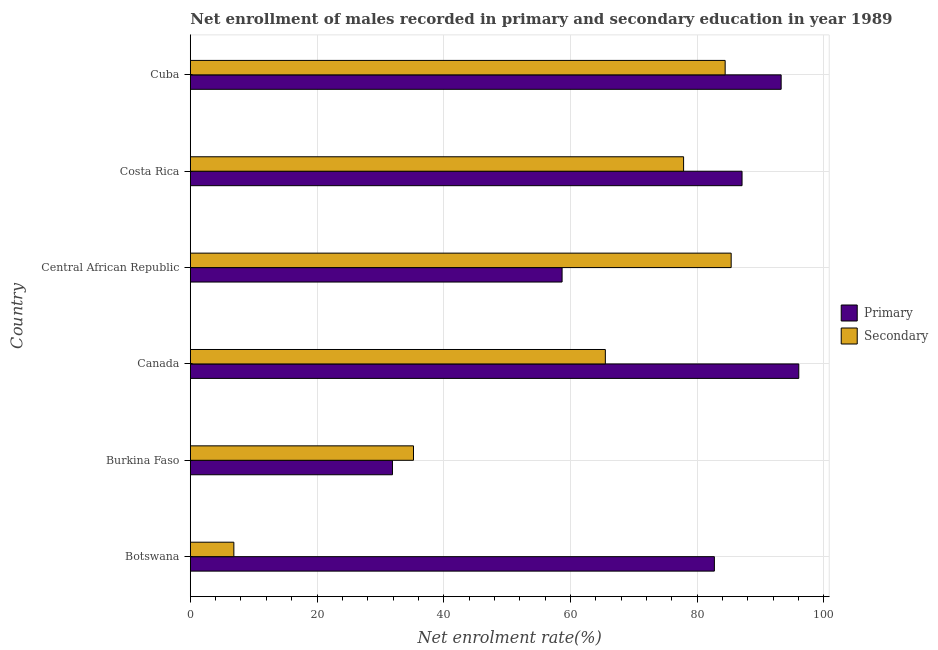How many different coloured bars are there?
Provide a succinct answer. 2. How many groups of bars are there?
Provide a short and direct response. 6. Are the number of bars on each tick of the Y-axis equal?
Your answer should be very brief. Yes. How many bars are there on the 3rd tick from the top?
Offer a very short reply. 2. What is the label of the 6th group of bars from the top?
Your response must be concise. Botswana. What is the enrollment rate in primary education in Burkina Faso?
Your answer should be compact. 31.91. Across all countries, what is the maximum enrollment rate in primary education?
Keep it short and to the point. 96.04. Across all countries, what is the minimum enrollment rate in secondary education?
Provide a succinct answer. 6.88. In which country was the enrollment rate in secondary education maximum?
Make the answer very short. Central African Republic. In which country was the enrollment rate in primary education minimum?
Offer a terse response. Burkina Faso. What is the total enrollment rate in secondary education in the graph?
Provide a succinct answer. 355.25. What is the difference between the enrollment rate in primary education in Canada and that in Cuba?
Provide a short and direct response. 2.78. What is the difference between the enrollment rate in secondary education in Central African Republic and the enrollment rate in primary education in Burkina Faso?
Offer a very short reply. 53.46. What is the average enrollment rate in primary education per country?
Keep it short and to the point. 74.95. What is the difference between the enrollment rate in primary education and enrollment rate in secondary education in Botswana?
Offer a terse response. 75.84. What is the ratio of the enrollment rate in secondary education in Botswana to that in Costa Rica?
Your response must be concise. 0.09. Is the enrollment rate in primary education in Burkina Faso less than that in Canada?
Give a very brief answer. Yes. Is the difference between the enrollment rate in primary education in Botswana and Central African Republic greater than the difference between the enrollment rate in secondary education in Botswana and Central African Republic?
Give a very brief answer. Yes. What is the difference between the highest and the second highest enrollment rate in primary education?
Your response must be concise. 2.78. What is the difference between the highest and the lowest enrollment rate in secondary education?
Provide a short and direct response. 78.49. In how many countries, is the enrollment rate in primary education greater than the average enrollment rate in primary education taken over all countries?
Provide a succinct answer. 4. What does the 2nd bar from the top in Costa Rica represents?
Provide a short and direct response. Primary. What does the 2nd bar from the bottom in Canada represents?
Offer a terse response. Secondary. Are all the bars in the graph horizontal?
Provide a short and direct response. Yes. How many countries are there in the graph?
Your answer should be very brief. 6. What is the difference between two consecutive major ticks on the X-axis?
Provide a succinct answer. 20. Are the values on the major ticks of X-axis written in scientific E-notation?
Your response must be concise. No. Does the graph contain grids?
Your answer should be compact. Yes. How many legend labels are there?
Your answer should be very brief. 2. What is the title of the graph?
Ensure brevity in your answer.  Net enrollment of males recorded in primary and secondary education in year 1989. Does "National Visitors" appear as one of the legend labels in the graph?
Provide a short and direct response. No. What is the label or title of the X-axis?
Your answer should be very brief. Net enrolment rate(%). What is the label or title of the Y-axis?
Give a very brief answer. Country. What is the Net enrolment rate(%) in Primary in Botswana?
Offer a terse response. 82.72. What is the Net enrolment rate(%) of Secondary in Botswana?
Provide a short and direct response. 6.88. What is the Net enrolment rate(%) of Primary in Burkina Faso?
Your answer should be very brief. 31.91. What is the Net enrolment rate(%) of Secondary in Burkina Faso?
Your answer should be very brief. 35.23. What is the Net enrolment rate(%) in Primary in Canada?
Offer a very short reply. 96.04. What is the Net enrolment rate(%) in Secondary in Canada?
Offer a very short reply. 65.51. What is the Net enrolment rate(%) in Primary in Central African Republic?
Offer a terse response. 58.68. What is the Net enrolment rate(%) of Secondary in Central African Republic?
Ensure brevity in your answer.  85.37. What is the Net enrolment rate(%) of Primary in Costa Rica?
Offer a very short reply. 87.08. What is the Net enrolment rate(%) of Secondary in Costa Rica?
Make the answer very short. 77.86. What is the Net enrolment rate(%) of Primary in Cuba?
Ensure brevity in your answer.  93.25. What is the Net enrolment rate(%) of Secondary in Cuba?
Provide a short and direct response. 84.42. Across all countries, what is the maximum Net enrolment rate(%) of Primary?
Make the answer very short. 96.04. Across all countries, what is the maximum Net enrolment rate(%) of Secondary?
Your answer should be very brief. 85.37. Across all countries, what is the minimum Net enrolment rate(%) in Primary?
Your response must be concise. 31.91. Across all countries, what is the minimum Net enrolment rate(%) in Secondary?
Offer a terse response. 6.88. What is the total Net enrolment rate(%) in Primary in the graph?
Your answer should be very brief. 449.68. What is the total Net enrolment rate(%) of Secondary in the graph?
Provide a short and direct response. 355.25. What is the difference between the Net enrolment rate(%) in Primary in Botswana and that in Burkina Faso?
Keep it short and to the point. 50.81. What is the difference between the Net enrolment rate(%) of Secondary in Botswana and that in Burkina Faso?
Offer a terse response. -28.35. What is the difference between the Net enrolment rate(%) in Primary in Botswana and that in Canada?
Your answer should be very brief. -13.32. What is the difference between the Net enrolment rate(%) of Secondary in Botswana and that in Canada?
Make the answer very short. -58.63. What is the difference between the Net enrolment rate(%) in Primary in Botswana and that in Central African Republic?
Provide a short and direct response. 24.04. What is the difference between the Net enrolment rate(%) of Secondary in Botswana and that in Central African Republic?
Your response must be concise. -78.49. What is the difference between the Net enrolment rate(%) in Primary in Botswana and that in Costa Rica?
Provide a succinct answer. -4.37. What is the difference between the Net enrolment rate(%) of Secondary in Botswana and that in Costa Rica?
Ensure brevity in your answer.  -70.98. What is the difference between the Net enrolment rate(%) in Primary in Botswana and that in Cuba?
Offer a very short reply. -10.54. What is the difference between the Net enrolment rate(%) of Secondary in Botswana and that in Cuba?
Provide a short and direct response. -77.54. What is the difference between the Net enrolment rate(%) in Primary in Burkina Faso and that in Canada?
Your answer should be compact. -64.13. What is the difference between the Net enrolment rate(%) of Secondary in Burkina Faso and that in Canada?
Ensure brevity in your answer.  -30.28. What is the difference between the Net enrolment rate(%) in Primary in Burkina Faso and that in Central African Republic?
Your response must be concise. -26.77. What is the difference between the Net enrolment rate(%) of Secondary in Burkina Faso and that in Central African Republic?
Provide a succinct answer. -50.14. What is the difference between the Net enrolment rate(%) in Primary in Burkina Faso and that in Costa Rica?
Your answer should be compact. -55.17. What is the difference between the Net enrolment rate(%) in Secondary in Burkina Faso and that in Costa Rica?
Ensure brevity in your answer.  -42.63. What is the difference between the Net enrolment rate(%) of Primary in Burkina Faso and that in Cuba?
Offer a terse response. -61.35. What is the difference between the Net enrolment rate(%) of Secondary in Burkina Faso and that in Cuba?
Offer a very short reply. -49.19. What is the difference between the Net enrolment rate(%) in Primary in Canada and that in Central African Republic?
Make the answer very short. 37.36. What is the difference between the Net enrolment rate(%) of Secondary in Canada and that in Central African Republic?
Your answer should be compact. -19.86. What is the difference between the Net enrolment rate(%) in Primary in Canada and that in Costa Rica?
Provide a succinct answer. 8.96. What is the difference between the Net enrolment rate(%) in Secondary in Canada and that in Costa Rica?
Give a very brief answer. -12.35. What is the difference between the Net enrolment rate(%) of Primary in Canada and that in Cuba?
Offer a terse response. 2.78. What is the difference between the Net enrolment rate(%) of Secondary in Canada and that in Cuba?
Your answer should be very brief. -18.91. What is the difference between the Net enrolment rate(%) in Primary in Central African Republic and that in Costa Rica?
Make the answer very short. -28.4. What is the difference between the Net enrolment rate(%) in Secondary in Central African Republic and that in Costa Rica?
Your answer should be compact. 7.51. What is the difference between the Net enrolment rate(%) of Primary in Central African Republic and that in Cuba?
Ensure brevity in your answer.  -34.57. What is the difference between the Net enrolment rate(%) of Secondary in Central African Republic and that in Cuba?
Provide a succinct answer. 0.95. What is the difference between the Net enrolment rate(%) of Primary in Costa Rica and that in Cuba?
Your response must be concise. -6.17. What is the difference between the Net enrolment rate(%) of Secondary in Costa Rica and that in Cuba?
Your response must be concise. -6.56. What is the difference between the Net enrolment rate(%) in Primary in Botswana and the Net enrolment rate(%) in Secondary in Burkina Faso?
Offer a terse response. 47.49. What is the difference between the Net enrolment rate(%) in Primary in Botswana and the Net enrolment rate(%) in Secondary in Canada?
Keep it short and to the point. 17.21. What is the difference between the Net enrolment rate(%) of Primary in Botswana and the Net enrolment rate(%) of Secondary in Central African Republic?
Your response must be concise. -2.65. What is the difference between the Net enrolment rate(%) in Primary in Botswana and the Net enrolment rate(%) in Secondary in Costa Rica?
Give a very brief answer. 4.86. What is the difference between the Net enrolment rate(%) of Primary in Botswana and the Net enrolment rate(%) of Secondary in Cuba?
Your response must be concise. -1.7. What is the difference between the Net enrolment rate(%) in Primary in Burkina Faso and the Net enrolment rate(%) in Secondary in Canada?
Your answer should be very brief. -33.6. What is the difference between the Net enrolment rate(%) in Primary in Burkina Faso and the Net enrolment rate(%) in Secondary in Central African Republic?
Your answer should be very brief. -53.46. What is the difference between the Net enrolment rate(%) of Primary in Burkina Faso and the Net enrolment rate(%) of Secondary in Costa Rica?
Ensure brevity in your answer.  -45.95. What is the difference between the Net enrolment rate(%) of Primary in Burkina Faso and the Net enrolment rate(%) of Secondary in Cuba?
Give a very brief answer. -52.51. What is the difference between the Net enrolment rate(%) in Primary in Canada and the Net enrolment rate(%) in Secondary in Central African Republic?
Ensure brevity in your answer.  10.67. What is the difference between the Net enrolment rate(%) in Primary in Canada and the Net enrolment rate(%) in Secondary in Costa Rica?
Keep it short and to the point. 18.18. What is the difference between the Net enrolment rate(%) in Primary in Canada and the Net enrolment rate(%) in Secondary in Cuba?
Offer a very short reply. 11.62. What is the difference between the Net enrolment rate(%) in Primary in Central African Republic and the Net enrolment rate(%) in Secondary in Costa Rica?
Provide a short and direct response. -19.18. What is the difference between the Net enrolment rate(%) in Primary in Central African Republic and the Net enrolment rate(%) in Secondary in Cuba?
Your response must be concise. -25.74. What is the difference between the Net enrolment rate(%) in Primary in Costa Rica and the Net enrolment rate(%) in Secondary in Cuba?
Ensure brevity in your answer.  2.67. What is the average Net enrolment rate(%) in Primary per country?
Your answer should be very brief. 74.95. What is the average Net enrolment rate(%) of Secondary per country?
Your answer should be very brief. 59.21. What is the difference between the Net enrolment rate(%) of Primary and Net enrolment rate(%) of Secondary in Botswana?
Your response must be concise. 75.84. What is the difference between the Net enrolment rate(%) of Primary and Net enrolment rate(%) of Secondary in Burkina Faso?
Give a very brief answer. -3.32. What is the difference between the Net enrolment rate(%) of Primary and Net enrolment rate(%) of Secondary in Canada?
Offer a very short reply. 30.53. What is the difference between the Net enrolment rate(%) of Primary and Net enrolment rate(%) of Secondary in Central African Republic?
Your answer should be compact. -26.69. What is the difference between the Net enrolment rate(%) in Primary and Net enrolment rate(%) in Secondary in Costa Rica?
Ensure brevity in your answer.  9.22. What is the difference between the Net enrolment rate(%) in Primary and Net enrolment rate(%) in Secondary in Cuba?
Your answer should be very brief. 8.84. What is the ratio of the Net enrolment rate(%) in Primary in Botswana to that in Burkina Faso?
Offer a very short reply. 2.59. What is the ratio of the Net enrolment rate(%) of Secondary in Botswana to that in Burkina Faso?
Make the answer very short. 0.2. What is the ratio of the Net enrolment rate(%) in Primary in Botswana to that in Canada?
Provide a succinct answer. 0.86. What is the ratio of the Net enrolment rate(%) in Secondary in Botswana to that in Canada?
Your answer should be compact. 0.1. What is the ratio of the Net enrolment rate(%) of Primary in Botswana to that in Central African Republic?
Give a very brief answer. 1.41. What is the ratio of the Net enrolment rate(%) in Secondary in Botswana to that in Central African Republic?
Offer a terse response. 0.08. What is the ratio of the Net enrolment rate(%) of Primary in Botswana to that in Costa Rica?
Your answer should be very brief. 0.95. What is the ratio of the Net enrolment rate(%) of Secondary in Botswana to that in Costa Rica?
Ensure brevity in your answer.  0.09. What is the ratio of the Net enrolment rate(%) in Primary in Botswana to that in Cuba?
Keep it short and to the point. 0.89. What is the ratio of the Net enrolment rate(%) of Secondary in Botswana to that in Cuba?
Your response must be concise. 0.08. What is the ratio of the Net enrolment rate(%) in Primary in Burkina Faso to that in Canada?
Make the answer very short. 0.33. What is the ratio of the Net enrolment rate(%) of Secondary in Burkina Faso to that in Canada?
Provide a succinct answer. 0.54. What is the ratio of the Net enrolment rate(%) of Primary in Burkina Faso to that in Central African Republic?
Provide a succinct answer. 0.54. What is the ratio of the Net enrolment rate(%) of Secondary in Burkina Faso to that in Central African Republic?
Provide a short and direct response. 0.41. What is the ratio of the Net enrolment rate(%) in Primary in Burkina Faso to that in Costa Rica?
Offer a very short reply. 0.37. What is the ratio of the Net enrolment rate(%) in Secondary in Burkina Faso to that in Costa Rica?
Keep it short and to the point. 0.45. What is the ratio of the Net enrolment rate(%) in Primary in Burkina Faso to that in Cuba?
Your answer should be compact. 0.34. What is the ratio of the Net enrolment rate(%) in Secondary in Burkina Faso to that in Cuba?
Give a very brief answer. 0.42. What is the ratio of the Net enrolment rate(%) of Primary in Canada to that in Central African Republic?
Make the answer very short. 1.64. What is the ratio of the Net enrolment rate(%) in Secondary in Canada to that in Central African Republic?
Offer a terse response. 0.77. What is the ratio of the Net enrolment rate(%) in Primary in Canada to that in Costa Rica?
Give a very brief answer. 1.1. What is the ratio of the Net enrolment rate(%) of Secondary in Canada to that in Costa Rica?
Offer a very short reply. 0.84. What is the ratio of the Net enrolment rate(%) of Primary in Canada to that in Cuba?
Offer a very short reply. 1.03. What is the ratio of the Net enrolment rate(%) of Secondary in Canada to that in Cuba?
Make the answer very short. 0.78. What is the ratio of the Net enrolment rate(%) in Primary in Central African Republic to that in Costa Rica?
Ensure brevity in your answer.  0.67. What is the ratio of the Net enrolment rate(%) of Secondary in Central African Republic to that in Costa Rica?
Provide a succinct answer. 1.1. What is the ratio of the Net enrolment rate(%) of Primary in Central African Republic to that in Cuba?
Keep it short and to the point. 0.63. What is the ratio of the Net enrolment rate(%) in Secondary in Central African Republic to that in Cuba?
Offer a very short reply. 1.01. What is the ratio of the Net enrolment rate(%) of Primary in Costa Rica to that in Cuba?
Provide a short and direct response. 0.93. What is the ratio of the Net enrolment rate(%) of Secondary in Costa Rica to that in Cuba?
Offer a very short reply. 0.92. What is the difference between the highest and the second highest Net enrolment rate(%) of Primary?
Offer a very short reply. 2.78. What is the difference between the highest and the second highest Net enrolment rate(%) of Secondary?
Provide a succinct answer. 0.95. What is the difference between the highest and the lowest Net enrolment rate(%) in Primary?
Provide a succinct answer. 64.13. What is the difference between the highest and the lowest Net enrolment rate(%) in Secondary?
Provide a short and direct response. 78.49. 